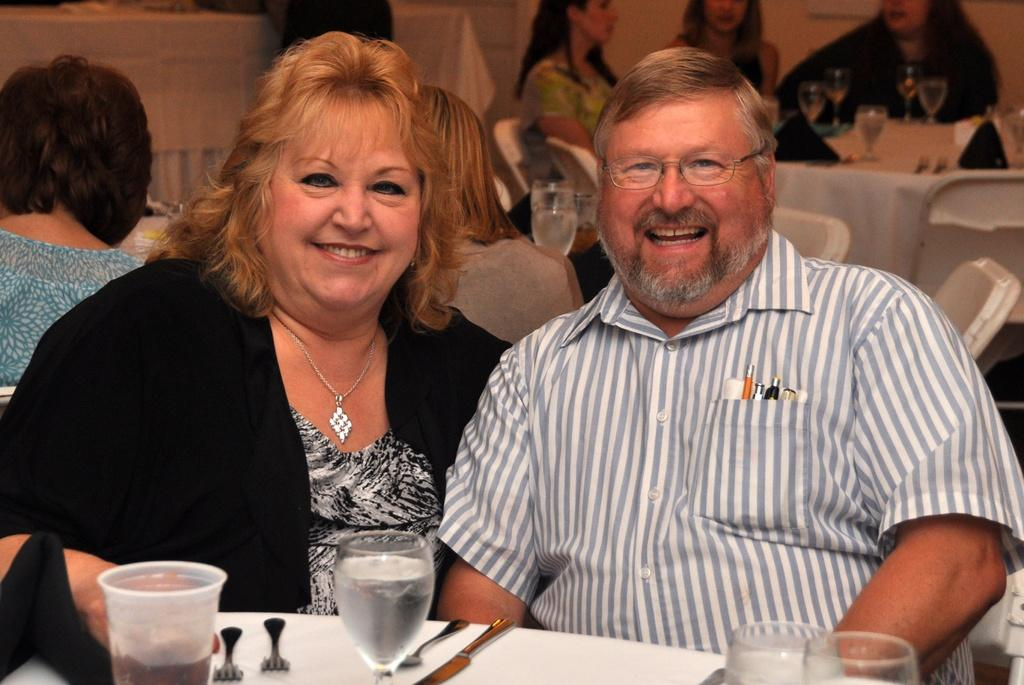What are the people in the image doing? The people in the image are sitting on chairs near a table. What items can be seen on the table? There are napkins, glasses, and forks on the table. How many people are in the image? There is a man and a woman in the image. What is the facial expression of the people in the image? Both the man and the woman are smiling. What type of ornament is hanging above the crib in the image? There is no crib or ornament present in the image. What time of day is depicted in the image? The provided facts do not mention the time of day, so it cannot be determined from the image. 